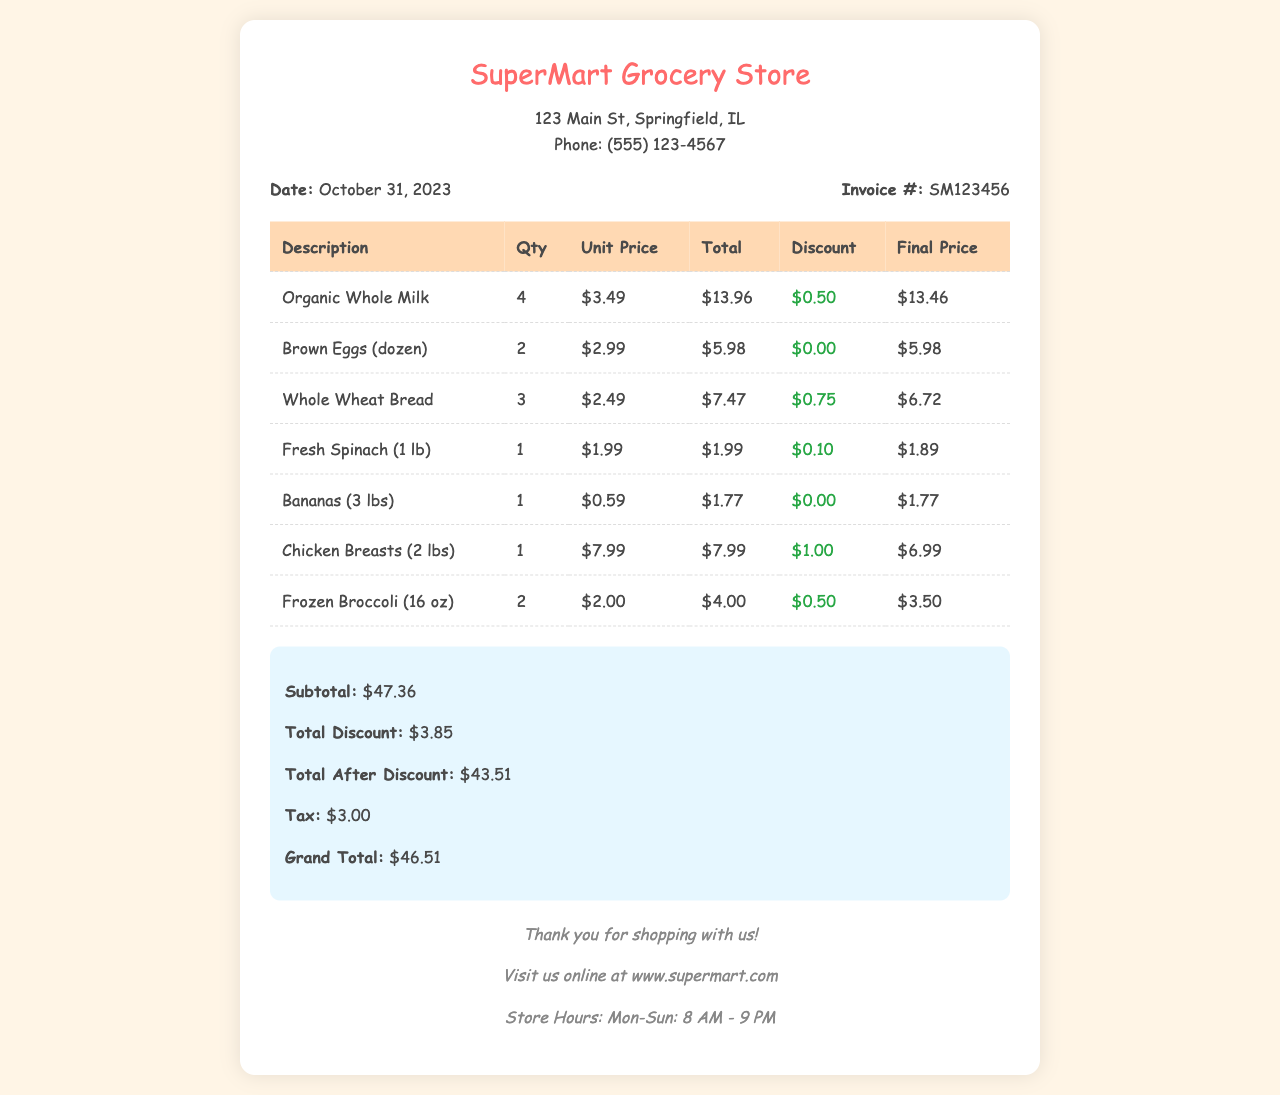What is the date of the invoice? The date is mentioned prominently in the invoice details section, which states it is October 31, 2023.
Answer: October 31, 2023 What is the invoice number? The invoice number can be found near the date, labeled as "Invoice #", which is SM123456.
Answer: SM123456 How many organic whole milk cartons were purchased? The quantity of organic whole milk is listed in the itemization under the "Qty" column, which shows 4.
Answer: 4 What is the total discount given on the purchases? The total discount is summarized at the bottom of the invoice, which states $3.85.
Answer: $3.85 What is the grand total after tax for the purchase? The grand total is mentioned at the end of the summary section, which includes tax, totaling $46.51.
Answer: $46.51 Which item had the highest unit price? Looking through the item prices, chicken breasts have the highest unit price at $7.99 per pound.
Answer: Chicken Breasts What was the subtotal before any discounts? The subtotal can be found in the summary, which indicates a subtotal of $47.36.
Answer: $47.36 What is the total tax applied to the invoice? The tax amount is detailed in the summary section, which states it is $3.00.
Answer: $3.00 How many units of frozen broccoli were purchased? The quantity of frozen broccoli can be found in the itemized section, indicating 2 units were bought.
Answer: 2 